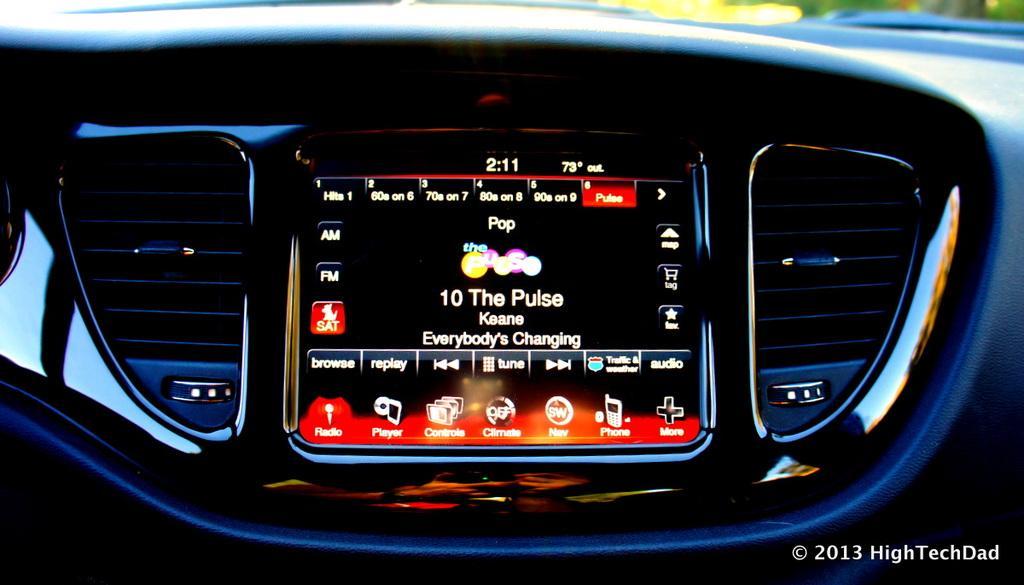In one or two sentences, can you explain what this image depicts? In the image we can see the internal structure of the vehicle, this is a watermark and a screen. 